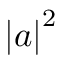<formula> <loc_0><loc_0><loc_500><loc_500>\left | a \right | ^ { 2 }</formula> 